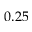Convert formula to latex. <formula><loc_0><loc_0><loc_500><loc_500>0 . 2 5</formula> 